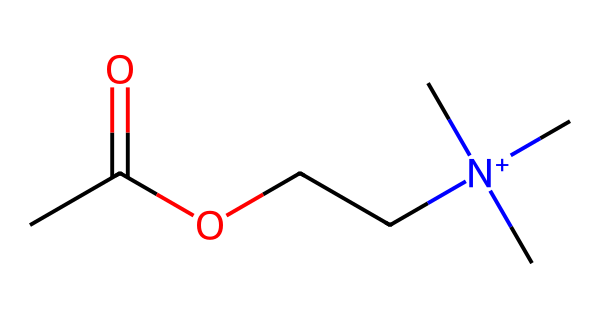What is the molecular formula of acetylcholine? To determine the molecular formula, we can identify the types and numbers of atoms in the SMILES representation. From the SMILES, we see there are 4 carbon (C) atoms, 10 hydrogen (H) atoms, 1 nitrogen (N) atom, and 2 oxygen (O) atoms. Therefore, the molecular formula is C4H10N1O2.
Answer: C4H10N1O2 How many functional groups are present in acetylcholine? By analyzing the structure indicated by the SMILES, we identify that acetylcholine has an ester group (from "CC(=O)O") and a quaternary ammonium group (from "[N+](C)(C)C"). This gives us two functional groups in total.
Answer: 2 What type of chemical is acetylcholine classified as? Acetylcholine is involved in neurotransmission and is primarily classified as a neurotransmitter due to its role in transmitting signals in the nervous system.
Answer: neurotransmitter Which atom is responsible for the positive charge in acetylcholine? The nitrogen atom in the quaternary ammonium group is indicated by "[N+]" in the SMILES, and it carries a positive charge due to the presence of four carbon groups attached to it.
Answer: nitrogen What is the significance of the acetate group in acetylcholine? The acetate group (CC(=O)O) provides acetylcholine its ester functional characteristics, contributing to its reactivity and role in neurotransmission as it facilitates hydrolysis by acetic acid and choline distinctively affecting signaling.
Answer: reactivity How many carbon atoms are directly attached to the nitrogen in acetylcholine? In the SMILES representation, the part "[N+](C)(C)C" shows that three carbon groups are directly attached to the positively charged nitrogen atom, which means there are three carbon atoms connected to nitrogen.
Answer: 3 